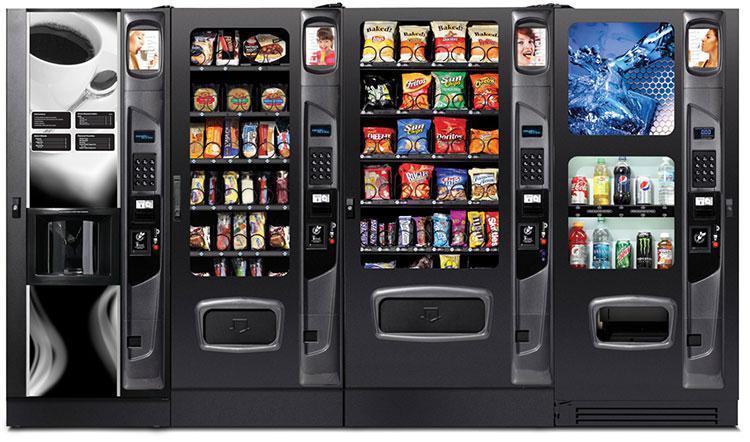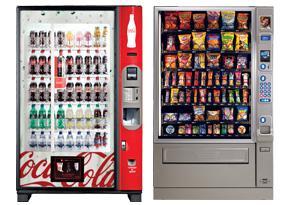The first image is the image on the left, the second image is the image on the right. For the images shown, is this caption "A bank of four vending machines is shown in one image." true? Answer yes or no. Yes. 